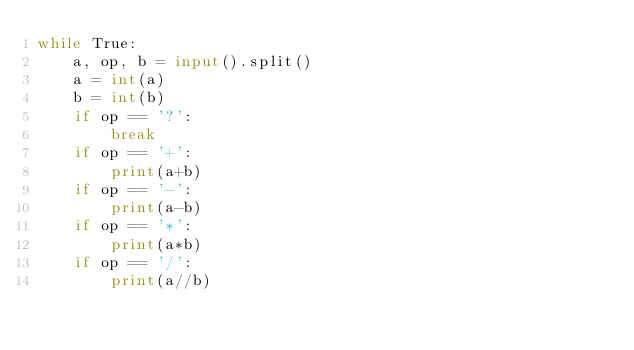Convert code to text. <code><loc_0><loc_0><loc_500><loc_500><_Python_>while True:
    a, op, b = input().split()
    a = int(a)
    b = int(b)
    if op == '?':
        break
    if op == '+':
        print(a+b)
    if op == '-':
        print(a-b)
    if op == '*':
        print(a*b)
    if op == '/':
        print(a//b)</code> 